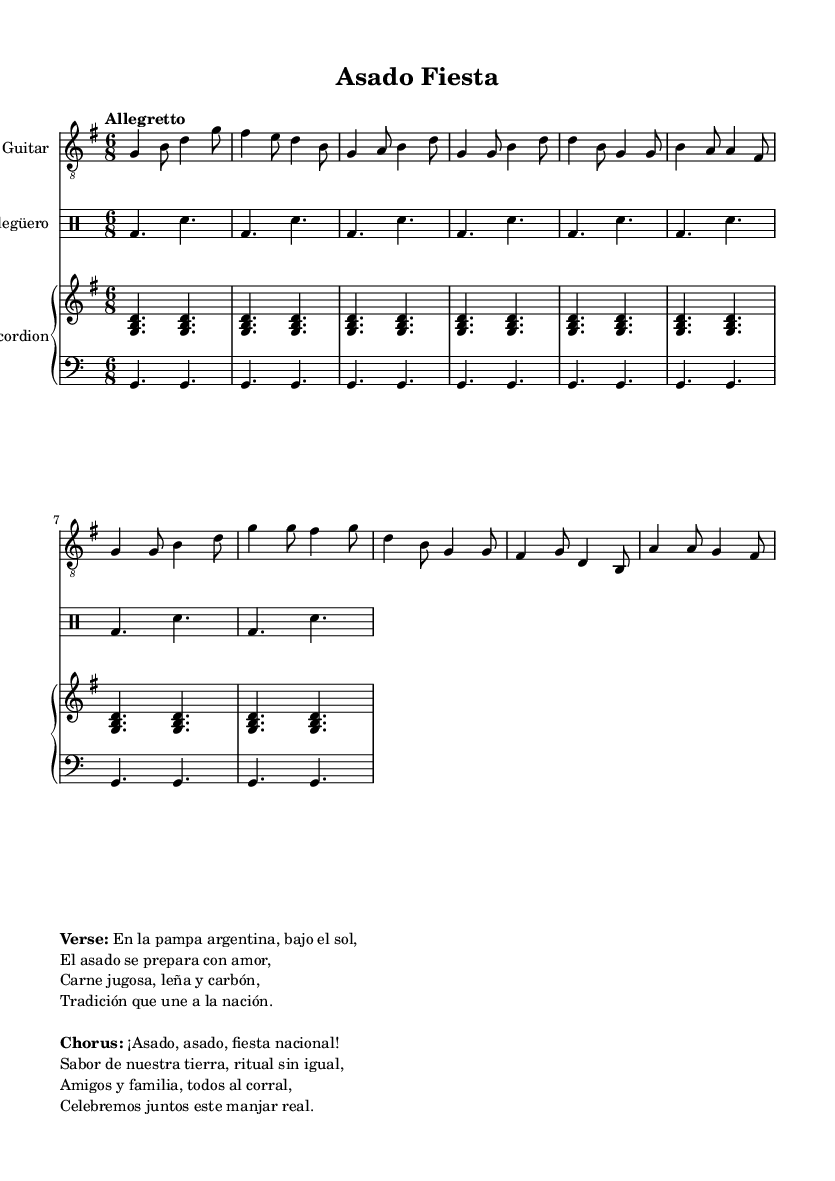What is the key signature of this music? The key signature is G major, which has one sharp (F#). This can be identified by looking at the key signature indicator at the beginning of the staff.
Answer: G major What is the time signature of this music? The time signature is 6/8, which can be found at the beginning of the score next to the key signature. This indicates that there are 6 eighth notes per measure.
Answer: 6/8 What is the tempo marking for this piece? The tempo marking is "Allegretto," which is indicated at the beginning of the score. This signifies a moderate pace that is faster than Allegro but slower than Andante.
Answer: Allegretto How many measures are in the verse of the song? The verse section is comprised of 4 measures. This can be determined by counting the measures indicated in the music notation for the verse.
Answer: 4 measures What is the instrument associated with the “Bombo legüero”? The “Bombo legüero” refers to a traditional Argentine drum. In the sheet music, it is labeled as the second instrument in the drum staff.
Answer: Drum What does the chorus celebrate? The chorus celebrates the national feast of asado, emphasizing its importance in Argentine culture, as indicated by the lyrics of the chorus.
Answer: Fiesta nacional How is the asado described in the verse? The asado is described as being prepared with love and includes juicy meat, firewood, and charcoal, emphasizing the traditional practices of Argentine grilling.
Answer: Carne jugosa, leña y carbón 